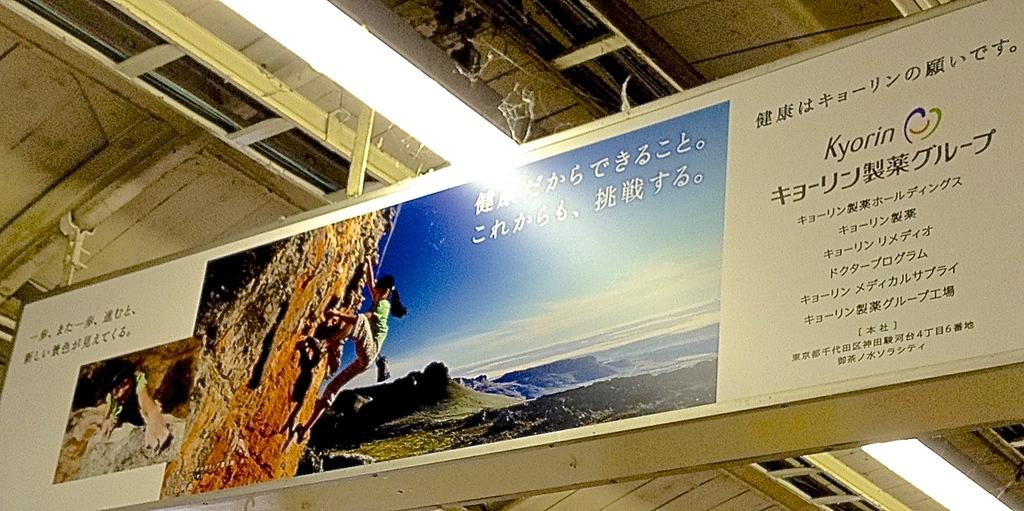What is the main subject of the image? There is a hoarding in the image. What is depicted on the hoarding? The hoarding features a person climbing a hill. Can you describe the light at the top of the image? Yes, there is a light at the top of the image. What is visible in the background of the image? The sky is visible in the image. How many dust particles can be seen floating in the air in the image? There is no mention of dust particles in the image, so it is not possible to determine their number. What type of wilderness can be seen in the background of the image? The image does not depict any wilderness; it features a hoarding with a person climbing a hill and a sky in the background. 